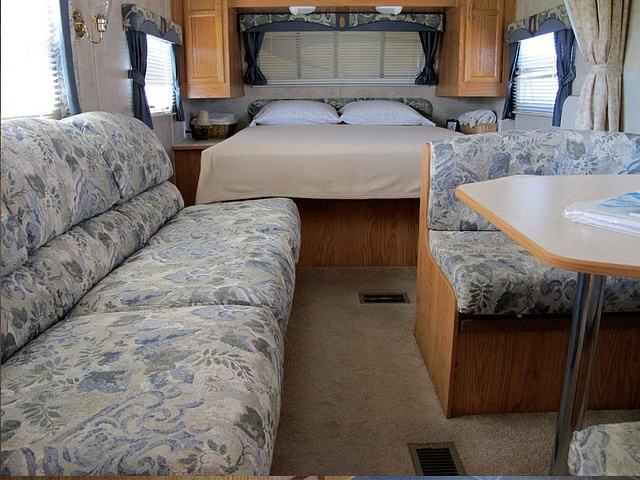Describe the objects in this image and their specific colors. I can see couch in black, darkgray, and gray tones, couch in black, darkgray, gray, and maroon tones, bed in black, darkgray, and gray tones, and dining table in black, darkgray, and lightgray tones in this image. 